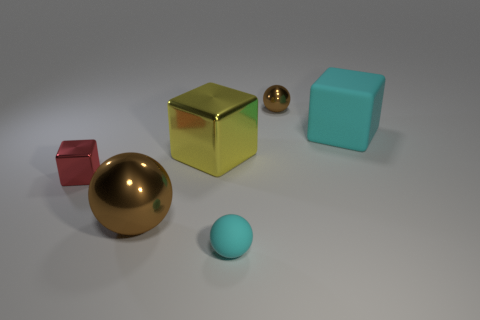How many cyan cubes are right of the object that is in front of the large metal thing that is in front of the tiny red thing?
Give a very brief answer. 1. How many big things are in front of the big cyan block and behind the large sphere?
Your answer should be compact. 1. There is a tiny matte thing that is the same color as the matte cube; what is its shape?
Offer a terse response. Sphere. Is the material of the large brown sphere the same as the big yellow object?
Ensure brevity in your answer.  Yes. What shape is the tiny metallic thing that is in front of the shiny ball that is behind the red cube that is in front of the large rubber cube?
Provide a short and direct response. Cube. Are there fewer brown balls that are on the left side of the small brown object than large yellow blocks left of the big metallic cube?
Ensure brevity in your answer.  No. What shape is the cyan matte object that is in front of the yellow cube that is to the right of the tiny red metallic object?
Make the answer very short. Sphere. Is there any other thing that is the same color as the small cube?
Give a very brief answer. No. Is the color of the tiny shiny block the same as the tiny matte object?
Provide a short and direct response. No. What number of yellow things are either large rubber things or large metallic things?
Your response must be concise. 1. 